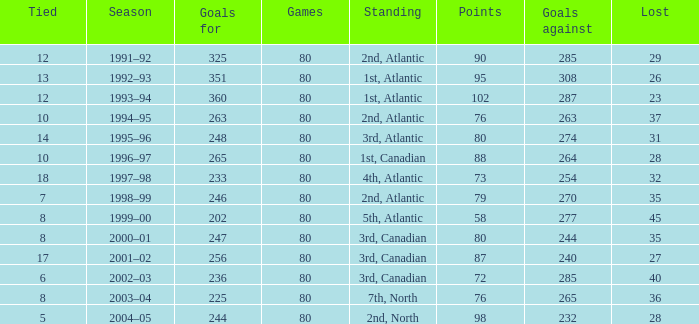How many goals against have 58 points? 277.0. 